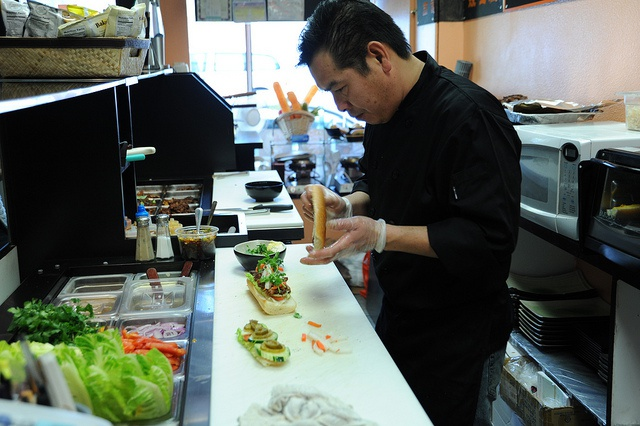Describe the objects in this image and their specific colors. I can see people in olive, black, maroon, and gray tones, microwave in olive, teal, lightblue, purple, and black tones, oven in olive, black, gray, darkgray, and purple tones, sandwich in olive, tan, beige, and darkgreen tones, and cup in olive, black, darkgray, and gray tones in this image. 